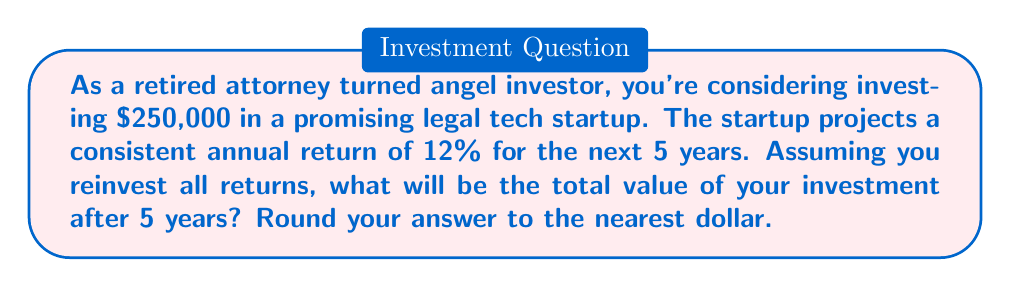Solve this math problem. To solve this problem, we'll use the compound interest formula:

$$A = P(1 + r)^n$$

Where:
$A$ = Final amount
$P$ = Principal (initial investment)
$r$ = Annual interest rate (as a decimal)
$n$ = Number of years

Given:
$P = \$250,000$
$r = 12\% = 0.12$
$n = 5$ years

Let's plug these values into the formula:

$$A = 250,000(1 + 0.12)^5$$

Now, let's calculate step by step:

1) First, calculate $(1 + 0.12)^5$:
   $$(1.12)^5 = 1.12 \times 1.12 \times 1.12 \times 1.12 \times 1.12 = 1.7623416$$

2) Now multiply this by the principal:
   $$250,000 \times 1.7623416 = 440,585.40$$

3) Rounding to the nearest dollar:
   $$440,585.40 \approx \$440,585$$

Therefore, after 5 years, your initial investment of $250,000 will grow to $440,585.
Answer: $440,585 